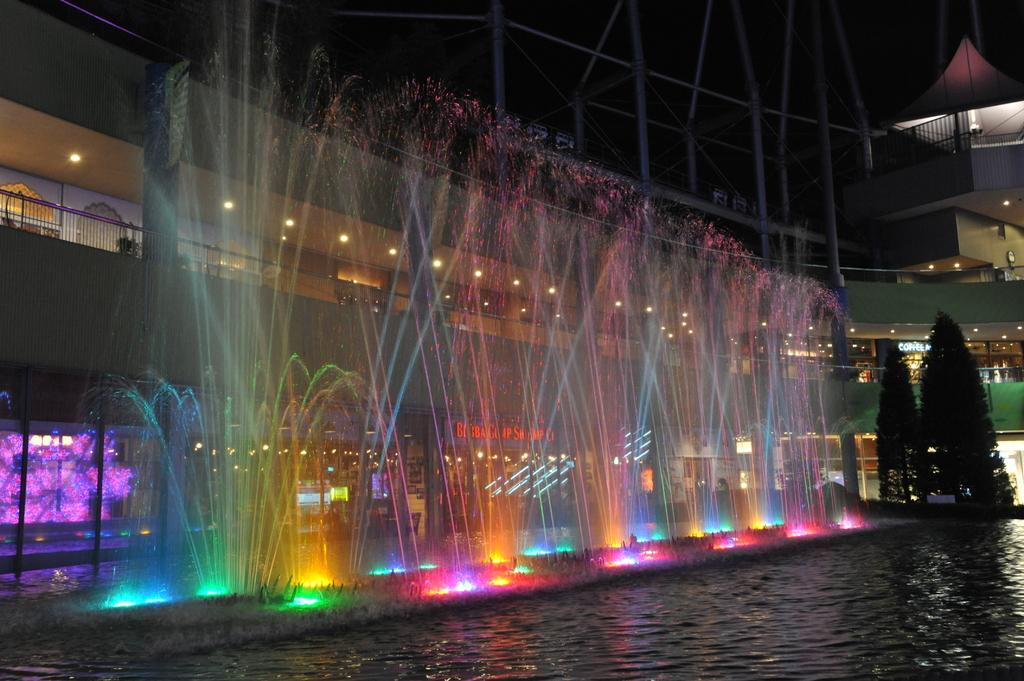What is the primary element present in the image? There is water in the image. What structures can be seen in the water? There are fountains in the image. What can be seen in the distance in the image? There are buildings, trees, and lights in the background of the image. What type of feather can be seen floating on the water in the image? There is no feather present in the image; it only features water and fountains. What shape is the lettuce in the image? There is no lettuce present in the image. 